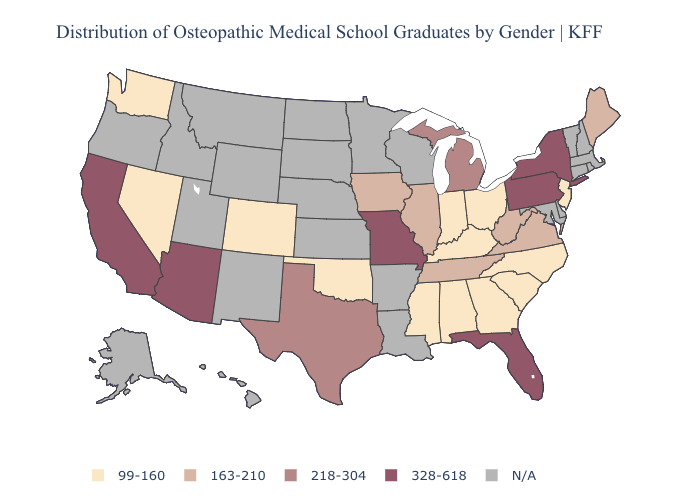Is the legend a continuous bar?
Write a very short answer. No. What is the value of Montana?
Give a very brief answer. N/A. What is the highest value in states that border New Jersey?
Short answer required. 328-618. Does California have the highest value in the USA?
Answer briefly. Yes. Which states have the lowest value in the USA?
Concise answer only. Alabama, Colorado, Georgia, Indiana, Kentucky, Mississippi, Nevada, New Jersey, North Carolina, Ohio, Oklahoma, South Carolina, Washington. What is the lowest value in the USA?
Quick response, please. 99-160. What is the highest value in states that border Oklahoma?
Write a very short answer. 328-618. Name the states that have a value in the range 99-160?
Quick response, please. Alabama, Colorado, Georgia, Indiana, Kentucky, Mississippi, Nevada, New Jersey, North Carolina, Ohio, Oklahoma, South Carolina, Washington. What is the value of New York?
Write a very short answer. 328-618. What is the value of Montana?
Quick response, please. N/A. What is the highest value in the West ?
Write a very short answer. 328-618. 